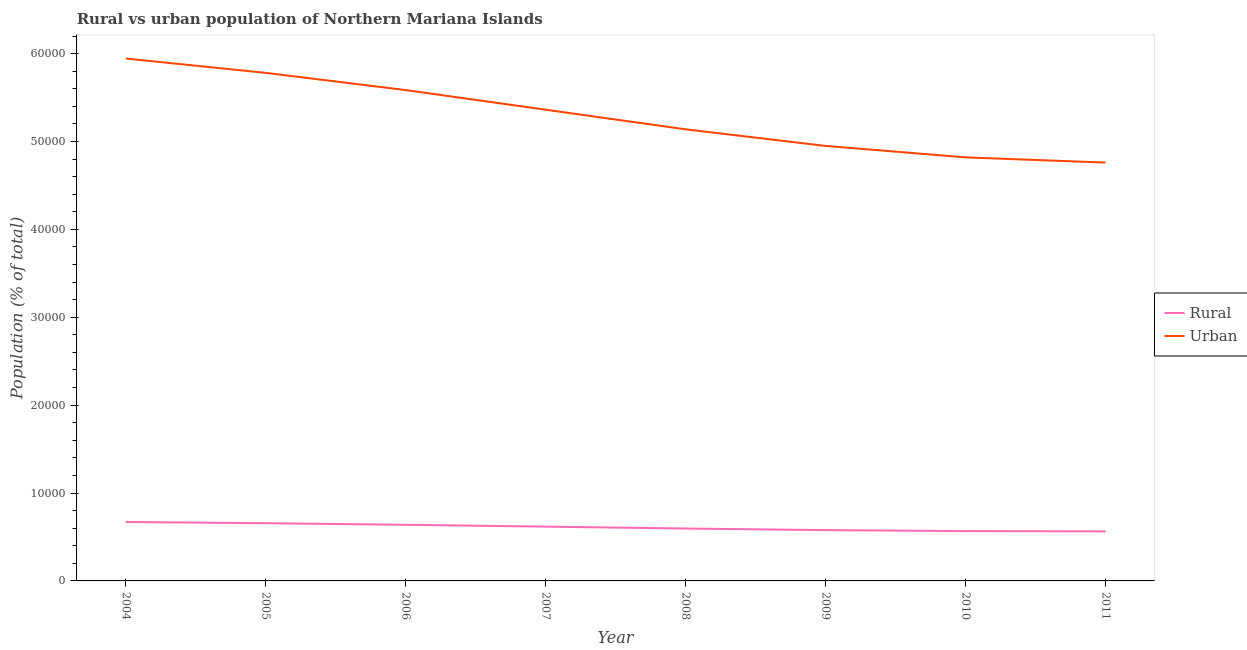How many different coloured lines are there?
Your answer should be very brief. 2. Does the line corresponding to urban population density intersect with the line corresponding to rural population density?
Ensure brevity in your answer.  No. What is the urban population density in 2005?
Provide a succinct answer. 5.78e+04. Across all years, what is the maximum rural population density?
Give a very brief answer. 6705. Across all years, what is the minimum rural population density?
Your answer should be very brief. 5635. In which year was the urban population density minimum?
Your answer should be very brief. 2011. What is the total urban population density in the graph?
Ensure brevity in your answer.  4.23e+05. What is the difference between the rural population density in 2004 and that in 2006?
Your answer should be very brief. 317. What is the difference between the rural population density in 2011 and the urban population density in 2005?
Provide a succinct answer. -5.22e+04. What is the average urban population density per year?
Keep it short and to the point. 5.29e+04. In the year 2007, what is the difference between the rural population density and urban population density?
Your answer should be compact. -4.74e+04. In how many years, is the urban population density greater than 22000 %?
Give a very brief answer. 8. What is the ratio of the urban population density in 2008 to that in 2010?
Make the answer very short. 1.07. Is the difference between the rural population density in 2008 and 2010 greater than the difference between the urban population density in 2008 and 2010?
Your answer should be compact. No. What is the difference between the highest and the second highest urban population density?
Your response must be concise. 1633. What is the difference between the highest and the lowest urban population density?
Your answer should be very brief. 1.18e+04. In how many years, is the rural population density greater than the average rural population density taken over all years?
Provide a short and direct response. 4. Does the urban population density monotonically increase over the years?
Your answer should be very brief. No. How many lines are there?
Provide a short and direct response. 2. How many years are there in the graph?
Provide a short and direct response. 8. What is the difference between two consecutive major ticks on the Y-axis?
Provide a short and direct response. 10000. Are the values on the major ticks of Y-axis written in scientific E-notation?
Your response must be concise. No. Does the graph contain grids?
Provide a succinct answer. No. How many legend labels are there?
Give a very brief answer. 2. How are the legend labels stacked?
Provide a succinct answer. Vertical. What is the title of the graph?
Offer a very short reply. Rural vs urban population of Northern Mariana Islands. Does "Female population" appear as one of the legend labels in the graph?
Offer a very short reply. No. What is the label or title of the X-axis?
Your answer should be compact. Year. What is the label or title of the Y-axis?
Keep it short and to the point. Population (% of total). What is the Population (% of total) in Rural in 2004?
Give a very brief answer. 6705. What is the Population (% of total) of Urban in 2004?
Make the answer very short. 5.94e+04. What is the Population (% of total) in Rural in 2005?
Your answer should be very brief. 6567. What is the Population (% of total) of Urban in 2005?
Offer a very short reply. 5.78e+04. What is the Population (% of total) in Rural in 2006?
Make the answer very short. 6388. What is the Population (% of total) of Urban in 2006?
Offer a terse response. 5.58e+04. What is the Population (% of total) of Rural in 2007?
Your response must be concise. 6176. What is the Population (% of total) of Urban in 2007?
Offer a terse response. 5.36e+04. What is the Population (% of total) in Rural in 2008?
Your response must be concise. 5961. What is the Population (% of total) in Urban in 2008?
Offer a terse response. 5.14e+04. What is the Population (% of total) in Rural in 2009?
Make the answer very short. 5782. What is the Population (% of total) in Urban in 2009?
Give a very brief answer. 4.95e+04. What is the Population (% of total) of Rural in 2010?
Your response must be concise. 5669. What is the Population (% of total) of Urban in 2010?
Offer a very short reply. 4.82e+04. What is the Population (% of total) in Rural in 2011?
Make the answer very short. 5635. What is the Population (% of total) in Urban in 2011?
Your response must be concise. 4.76e+04. Across all years, what is the maximum Population (% of total) of Rural?
Your answer should be very brief. 6705. Across all years, what is the maximum Population (% of total) of Urban?
Ensure brevity in your answer.  5.94e+04. Across all years, what is the minimum Population (% of total) in Rural?
Provide a succinct answer. 5635. Across all years, what is the minimum Population (% of total) in Urban?
Offer a very short reply. 4.76e+04. What is the total Population (% of total) in Rural in the graph?
Your response must be concise. 4.89e+04. What is the total Population (% of total) of Urban in the graph?
Your answer should be very brief. 4.23e+05. What is the difference between the Population (% of total) in Rural in 2004 and that in 2005?
Offer a very short reply. 138. What is the difference between the Population (% of total) in Urban in 2004 and that in 2005?
Your answer should be very brief. 1633. What is the difference between the Population (% of total) of Rural in 2004 and that in 2006?
Give a very brief answer. 317. What is the difference between the Population (% of total) in Urban in 2004 and that in 2006?
Provide a succinct answer. 3591. What is the difference between the Population (% of total) in Rural in 2004 and that in 2007?
Provide a succinct answer. 529. What is the difference between the Population (% of total) in Urban in 2004 and that in 2007?
Make the answer very short. 5823. What is the difference between the Population (% of total) of Rural in 2004 and that in 2008?
Provide a succinct answer. 744. What is the difference between the Population (% of total) of Urban in 2004 and that in 2008?
Provide a succinct answer. 8056. What is the difference between the Population (% of total) in Rural in 2004 and that in 2009?
Ensure brevity in your answer.  923. What is the difference between the Population (% of total) in Urban in 2004 and that in 2009?
Make the answer very short. 9944. What is the difference between the Population (% of total) of Rural in 2004 and that in 2010?
Give a very brief answer. 1036. What is the difference between the Population (% of total) in Urban in 2004 and that in 2010?
Provide a succinct answer. 1.12e+04. What is the difference between the Population (% of total) in Rural in 2004 and that in 2011?
Give a very brief answer. 1070. What is the difference between the Population (% of total) in Urban in 2004 and that in 2011?
Offer a very short reply. 1.18e+04. What is the difference between the Population (% of total) of Rural in 2005 and that in 2006?
Make the answer very short. 179. What is the difference between the Population (% of total) of Urban in 2005 and that in 2006?
Your answer should be very brief. 1958. What is the difference between the Population (% of total) in Rural in 2005 and that in 2007?
Provide a succinct answer. 391. What is the difference between the Population (% of total) of Urban in 2005 and that in 2007?
Your response must be concise. 4190. What is the difference between the Population (% of total) in Rural in 2005 and that in 2008?
Your response must be concise. 606. What is the difference between the Population (% of total) in Urban in 2005 and that in 2008?
Ensure brevity in your answer.  6423. What is the difference between the Population (% of total) in Rural in 2005 and that in 2009?
Ensure brevity in your answer.  785. What is the difference between the Population (% of total) in Urban in 2005 and that in 2009?
Offer a terse response. 8311. What is the difference between the Population (% of total) in Rural in 2005 and that in 2010?
Offer a very short reply. 898. What is the difference between the Population (% of total) in Urban in 2005 and that in 2010?
Offer a very short reply. 9614. What is the difference between the Population (% of total) of Rural in 2005 and that in 2011?
Offer a very short reply. 932. What is the difference between the Population (% of total) of Urban in 2005 and that in 2011?
Your response must be concise. 1.02e+04. What is the difference between the Population (% of total) of Rural in 2006 and that in 2007?
Keep it short and to the point. 212. What is the difference between the Population (% of total) of Urban in 2006 and that in 2007?
Ensure brevity in your answer.  2232. What is the difference between the Population (% of total) in Rural in 2006 and that in 2008?
Keep it short and to the point. 427. What is the difference between the Population (% of total) in Urban in 2006 and that in 2008?
Your answer should be compact. 4465. What is the difference between the Population (% of total) in Rural in 2006 and that in 2009?
Offer a terse response. 606. What is the difference between the Population (% of total) in Urban in 2006 and that in 2009?
Provide a succinct answer. 6353. What is the difference between the Population (% of total) of Rural in 2006 and that in 2010?
Your response must be concise. 719. What is the difference between the Population (% of total) of Urban in 2006 and that in 2010?
Give a very brief answer. 7656. What is the difference between the Population (% of total) in Rural in 2006 and that in 2011?
Make the answer very short. 753. What is the difference between the Population (% of total) of Urban in 2006 and that in 2011?
Ensure brevity in your answer.  8248. What is the difference between the Population (% of total) in Rural in 2007 and that in 2008?
Give a very brief answer. 215. What is the difference between the Population (% of total) in Urban in 2007 and that in 2008?
Provide a succinct answer. 2233. What is the difference between the Population (% of total) in Rural in 2007 and that in 2009?
Your answer should be compact. 394. What is the difference between the Population (% of total) of Urban in 2007 and that in 2009?
Make the answer very short. 4121. What is the difference between the Population (% of total) of Rural in 2007 and that in 2010?
Give a very brief answer. 507. What is the difference between the Population (% of total) in Urban in 2007 and that in 2010?
Your answer should be very brief. 5424. What is the difference between the Population (% of total) in Rural in 2007 and that in 2011?
Keep it short and to the point. 541. What is the difference between the Population (% of total) in Urban in 2007 and that in 2011?
Offer a terse response. 6016. What is the difference between the Population (% of total) of Rural in 2008 and that in 2009?
Your answer should be compact. 179. What is the difference between the Population (% of total) of Urban in 2008 and that in 2009?
Make the answer very short. 1888. What is the difference between the Population (% of total) in Rural in 2008 and that in 2010?
Provide a short and direct response. 292. What is the difference between the Population (% of total) of Urban in 2008 and that in 2010?
Ensure brevity in your answer.  3191. What is the difference between the Population (% of total) in Rural in 2008 and that in 2011?
Your response must be concise. 326. What is the difference between the Population (% of total) in Urban in 2008 and that in 2011?
Keep it short and to the point. 3783. What is the difference between the Population (% of total) in Rural in 2009 and that in 2010?
Your answer should be very brief. 113. What is the difference between the Population (% of total) in Urban in 2009 and that in 2010?
Give a very brief answer. 1303. What is the difference between the Population (% of total) in Rural in 2009 and that in 2011?
Provide a succinct answer. 147. What is the difference between the Population (% of total) of Urban in 2009 and that in 2011?
Your answer should be compact. 1895. What is the difference between the Population (% of total) in Rural in 2010 and that in 2011?
Your answer should be very brief. 34. What is the difference between the Population (% of total) of Urban in 2010 and that in 2011?
Give a very brief answer. 592. What is the difference between the Population (% of total) in Rural in 2004 and the Population (% of total) in Urban in 2005?
Provide a short and direct response. -5.11e+04. What is the difference between the Population (% of total) of Rural in 2004 and the Population (% of total) of Urban in 2006?
Your answer should be compact. -4.91e+04. What is the difference between the Population (% of total) of Rural in 2004 and the Population (% of total) of Urban in 2007?
Provide a short and direct response. -4.69e+04. What is the difference between the Population (% of total) of Rural in 2004 and the Population (% of total) of Urban in 2008?
Offer a very short reply. -4.47e+04. What is the difference between the Population (% of total) in Rural in 2004 and the Population (% of total) in Urban in 2009?
Provide a short and direct response. -4.28e+04. What is the difference between the Population (% of total) of Rural in 2004 and the Population (% of total) of Urban in 2010?
Ensure brevity in your answer.  -4.15e+04. What is the difference between the Population (% of total) in Rural in 2004 and the Population (% of total) in Urban in 2011?
Make the answer very short. -4.09e+04. What is the difference between the Population (% of total) of Rural in 2005 and the Population (% of total) of Urban in 2006?
Keep it short and to the point. -4.93e+04. What is the difference between the Population (% of total) in Rural in 2005 and the Population (% of total) in Urban in 2007?
Keep it short and to the point. -4.70e+04. What is the difference between the Population (% of total) of Rural in 2005 and the Population (% of total) of Urban in 2008?
Make the answer very short. -4.48e+04. What is the difference between the Population (% of total) in Rural in 2005 and the Population (% of total) in Urban in 2009?
Your answer should be very brief. -4.29e+04. What is the difference between the Population (% of total) of Rural in 2005 and the Population (% of total) of Urban in 2010?
Provide a succinct answer. -4.16e+04. What is the difference between the Population (% of total) in Rural in 2005 and the Population (% of total) in Urban in 2011?
Your answer should be compact. -4.10e+04. What is the difference between the Population (% of total) in Rural in 2006 and the Population (% of total) in Urban in 2007?
Your answer should be very brief. -4.72e+04. What is the difference between the Population (% of total) in Rural in 2006 and the Population (% of total) in Urban in 2008?
Your response must be concise. -4.50e+04. What is the difference between the Population (% of total) in Rural in 2006 and the Population (% of total) in Urban in 2009?
Your answer should be very brief. -4.31e+04. What is the difference between the Population (% of total) in Rural in 2006 and the Population (% of total) in Urban in 2010?
Keep it short and to the point. -4.18e+04. What is the difference between the Population (% of total) of Rural in 2006 and the Population (% of total) of Urban in 2011?
Give a very brief answer. -4.12e+04. What is the difference between the Population (% of total) in Rural in 2007 and the Population (% of total) in Urban in 2008?
Offer a very short reply. -4.52e+04. What is the difference between the Population (% of total) in Rural in 2007 and the Population (% of total) in Urban in 2009?
Make the answer very short. -4.33e+04. What is the difference between the Population (% of total) of Rural in 2007 and the Population (% of total) of Urban in 2010?
Your answer should be compact. -4.20e+04. What is the difference between the Population (% of total) of Rural in 2007 and the Population (% of total) of Urban in 2011?
Your response must be concise. -4.14e+04. What is the difference between the Population (% of total) of Rural in 2008 and the Population (% of total) of Urban in 2009?
Your response must be concise. -4.35e+04. What is the difference between the Population (% of total) of Rural in 2008 and the Population (% of total) of Urban in 2010?
Provide a short and direct response. -4.22e+04. What is the difference between the Population (% of total) in Rural in 2008 and the Population (% of total) in Urban in 2011?
Ensure brevity in your answer.  -4.16e+04. What is the difference between the Population (% of total) in Rural in 2009 and the Population (% of total) in Urban in 2010?
Make the answer very short. -4.24e+04. What is the difference between the Population (% of total) of Rural in 2009 and the Population (% of total) of Urban in 2011?
Your answer should be compact. -4.18e+04. What is the difference between the Population (% of total) in Rural in 2010 and the Population (% of total) in Urban in 2011?
Your response must be concise. -4.19e+04. What is the average Population (% of total) of Rural per year?
Offer a terse response. 6110.38. What is the average Population (% of total) in Urban per year?
Your response must be concise. 5.29e+04. In the year 2004, what is the difference between the Population (% of total) in Rural and Population (% of total) in Urban?
Offer a very short reply. -5.27e+04. In the year 2005, what is the difference between the Population (% of total) in Rural and Population (% of total) in Urban?
Make the answer very short. -5.12e+04. In the year 2006, what is the difference between the Population (% of total) of Rural and Population (% of total) of Urban?
Your answer should be compact. -4.95e+04. In the year 2007, what is the difference between the Population (% of total) of Rural and Population (% of total) of Urban?
Make the answer very short. -4.74e+04. In the year 2008, what is the difference between the Population (% of total) in Rural and Population (% of total) in Urban?
Your answer should be compact. -4.54e+04. In the year 2009, what is the difference between the Population (% of total) of Rural and Population (% of total) of Urban?
Your answer should be very brief. -4.37e+04. In the year 2010, what is the difference between the Population (% of total) of Rural and Population (% of total) of Urban?
Your response must be concise. -4.25e+04. In the year 2011, what is the difference between the Population (% of total) in Rural and Population (% of total) in Urban?
Give a very brief answer. -4.20e+04. What is the ratio of the Population (% of total) of Urban in 2004 to that in 2005?
Provide a succinct answer. 1.03. What is the ratio of the Population (% of total) of Rural in 2004 to that in 2006?
Offer a very short reply. 1.05. What is the ratio of the Population (% of total) in Urban in 2004 to that in 2006?
Your response must be concise. 1.06. What is the ratio of the Population (% of total) of Rural in 2004 to that in 2007?
Make the answer very short. 1.09. What is the ratio of the Population (% of total) of Urban in 2004 to that in 2007?
Make the answer very short. 1.11. What is the ratio of the Population (% of total) in Rural in 2004 to that in 2008?
Your answer should be compact. 1.12. What is the ratio of the Population (% of total) of Urban in 2004 to that in 2008?
Provide a short and direct response. 1.16. What is the ratio of the Population (% of total) of Rural in 2004 to that in 2009?
Your answer should be very brief. 1.16. What is the ratio of the Population (% of total) in Urban in 2004 to that in 2009?
Provide a short and direct response. 1.2. What is the ratio of the Population (% of total) in Rural in 2004 to that in 2010?
Your answer should be very brief. 1.18. What is the ratio of the Population (% of total) of Urban in 2004 to that in 2010?
Give a very brief answer. 1.23. What is the ratio of the Population (% of total) of Rural in 2004 to that in 2011?
Your answer should be very brief. 1.19. What is the ratio of the Population (% of total) of Urban in 2004 to that in 2011?
Keep it short and to the point. 1.25. What is the ratio of the Population (% of total) of Rural in 2005 to that in 2006?
Your answer should be very brief. 1.03. What is the ratio of the Population (% of total) of Urban in 2005 to that in 2006?
Make the answer very short. 1.04. What is the ratio of the Population (% of total) of Rural in 2005 to that in 2007?
Your answer should be very brief. 1.06. What is the ratio of the Population (% of total) of Urban in 2005 to that in 2007?
Give a very brief answer. 1.08. What is the ratio of the Population (% of total) in Rural in 2005 to that in 2008?
Offer a very short reply. 1.1. What is the ratio of the Population (% of total) of Urban in 2005 to that in 2008?
Offer a very short reply. 1.12. What is the ratio of the Population (% of total) of Rural in 2005 to that in 2009?
Provide a succinct answer. 1.14. What is the ratio of the Population (% of total) of Urban in 2005 to that in 2009?
Your response must be concise. 1.17. What is the ratio of the Population (% of total) in Rural in 2005 to that in 2010?
Your answer should be compact. 1.16. What is the ratio of the Population (% of total) of Urban in 2005 to that in 2010?
Your response must be concise. 1.2. What is the ratio of the Population (% of total) in Rural in 2005 to that in 2011?
Your answer should be very brief. 1.17. What is the ratio of the Population (% of total) in Urban in 2005 to that in 2011?
Your response must be concise. 1.21. What is the ratio of the Population (% of total) of Rural in 2006 to that in 2007?
Make the answer very short. 1.03. What is the ratio of the Population (% of total) of Urban in 2006 to that in 2007?
Your answer should be compact. 1.04. What is the ratio of the Population (% of total) of Rural in 2006 to that in 2008?
Give a very brief answer. 1.07. What is the ratio of the Population (% of total) in Urban in 2006 to that in 2008?
Give a very brief answer. 1.09. What is the ratio of the Population (% of total) in Rural in 2006 to that in 2009?
Offer a terse response. 1.1. What is the ratio of the Population (% of total) of Urban in 2006 to that in 2009?
Give a very brief answer. 1.13. What is the ratio of the Population (% of total) in Rural in 2006 to that in 2010?
Your answer should be very brief. 1.13. What is the ratio of the Population (% of total) in Urban in 2006 to that in 2010?
Make the answer very short. 1.16. What is the ratio of the Population (% of total) of Rural in 2006 to that in 2011?
Keep it short and to the point. 1.13. What is the ratio of the Population (% of total) of Urban in 2006 to that in 2011?
Make the answer very short. 1.17. What is the ratio of the Population (% of total) in Rural in 2007 to that in 2008?
Offer a terse response. 1.04. What is the ratio of the Population (% of total) of Urban in 2007 to that in 2008?
Your response must be concise. 1.04. What is the ratio of the Population (% of total) of Rural in 2007 to that in 2009?
Offer a very short reply. 1.07. What is the ratio of the Population (% of total) of Urban in 2007 to that in 2009?
Give a very brief answer. 1.08. What is the ratio of the Population (% of total) of Rural in 2007 to that in 2010?
Ensure brevity in your answer.  1.09. What is the ratio of the Population (% of total) of Urban in 2007 to that in 2010?
Offer a very short reply. 1.11. What is the ratio of the Population (% of total) of Rural in 2007 to that in 2011?
Give a very brief answer. 1.1. What is the ratio of the Population (% of total) in Urban in 2007 to that in 2011?
Your answer should be very brief. 1.13. What is the ratio of the Population (% of total) of Rural in 2008 to that in 2009?
Your response must be concise. 1.03. What is the ratio of the Population (% of total) of Urban in 2008 to that in 2009?
Provide a succinct answer. 1.04. What is the ratio of the Population (% of total) in Rural in 2008 to that in 2010?
Make the answer very short. 1.05. What is the ratio of the Population (% of total) in Urban in 2008 to that in 2010?
Ensure brevity in your answer.  1.07. What is the ratio of the Population (% of total) of Rural in 2008 to that in 2011?
Ensure brevity in your answer.  1.06. What is the ratio of the Population (% of total) in Urban in 2008 to that in 2011?
Provide a succinct answer. 1.08. What is the ratio of the Population (% of total) of Rural in 2009 to that in 2010?
Offer a terse response. 1.02. What is the ratio of the Population (% of total) in Urban in 2009 to that in 2010?
Your response must be concise. 1.03. What is the ratio of the Population (% of total) in Rural in 2009 to that in 2011?
Ensure brevity in your answer.  1.03. What is the ratio of the Population (% of total) of Urban in 2009 to that in 2011?
Offer a very short reply. 1.04. What is the ratio of the Population (% of total) of Rural in 2010 to that in 2011?
Provide a succinct answer. 1.01. What is the ratio of the Population (% of total) of Urban in 2010 to that in 2011?
Offer a terse response. 1.01. What is the difference between the highest and the second highest Population (% of total) of Rural?
Offer a very short reply. 138. What is the difference between the highest and the second highest Population (% of total) of Urban?
Your answer should be very brief. 1633. What is the difference between the highest and the lowest Population (% of total) in Rural?
Your answer should be very brief. 1070. What is the difference between the highest and the lowest Population (% of total) in Urban?
Provide a succinct answer. 1.18e+04. 